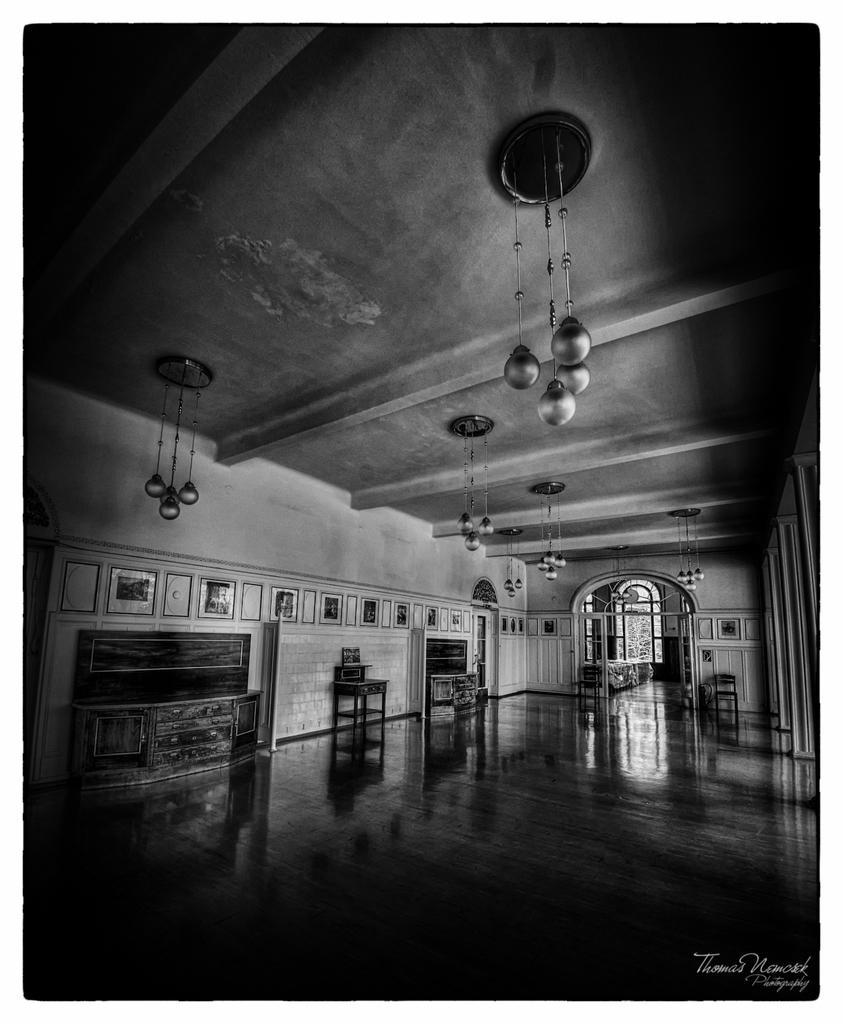Please provide a concise description of this image. This is a black and white image. On the bottom right, there is a watermark. At the bottom of this image, there is a floor of a building. In the background, there are lights attached to the roof, there are photo frames attached to the walls of the buildings, there are cupboards and other objects. 